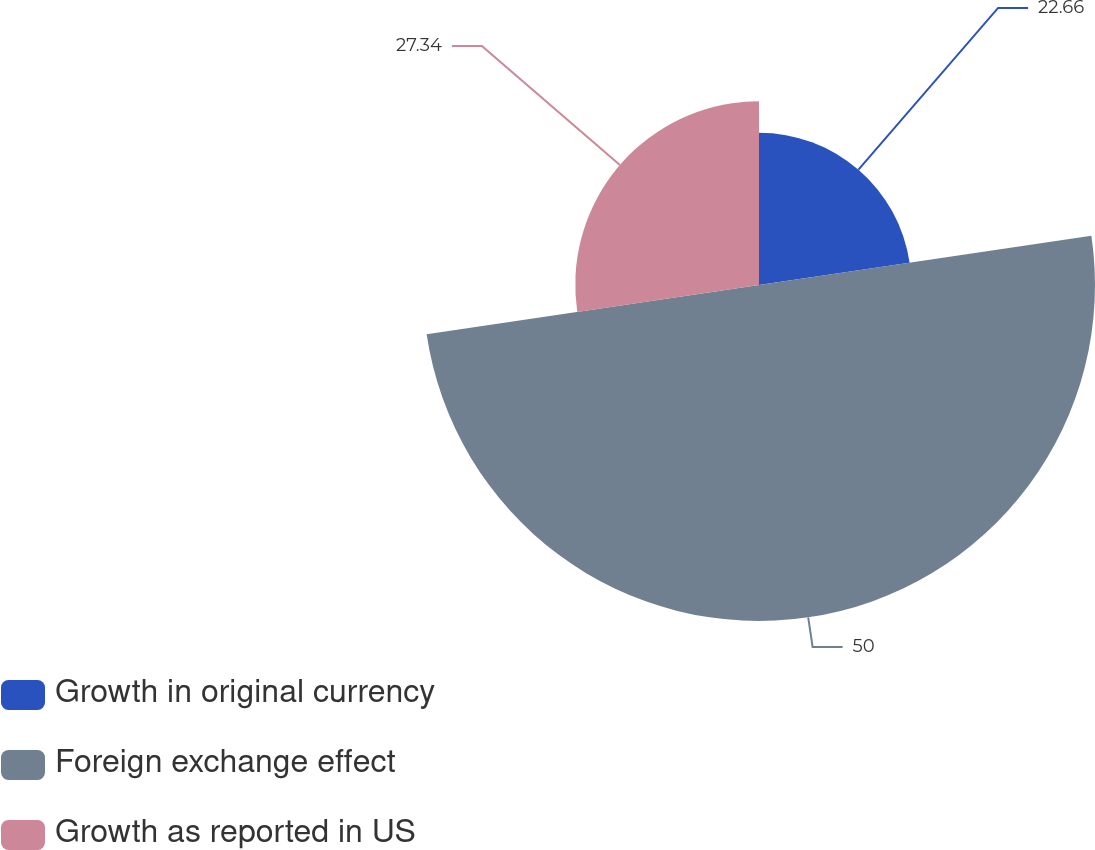Convert chart. <chart><loc_0><loc_0><loc_500><loc_500><pie_chart><fcel>Growth in original currency<fcel>Foreign exchange effect<fcel>Growth as reported in US<nl><fcel>22.66%<fcel>50.0%<fcel>27.34%<nl></chart> 